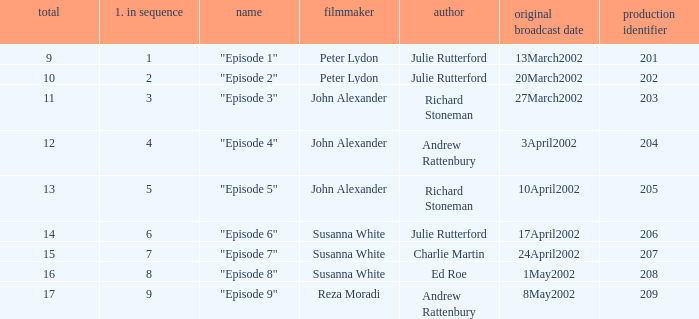When 1 is the number in series who is the director? Peter Lydon. 